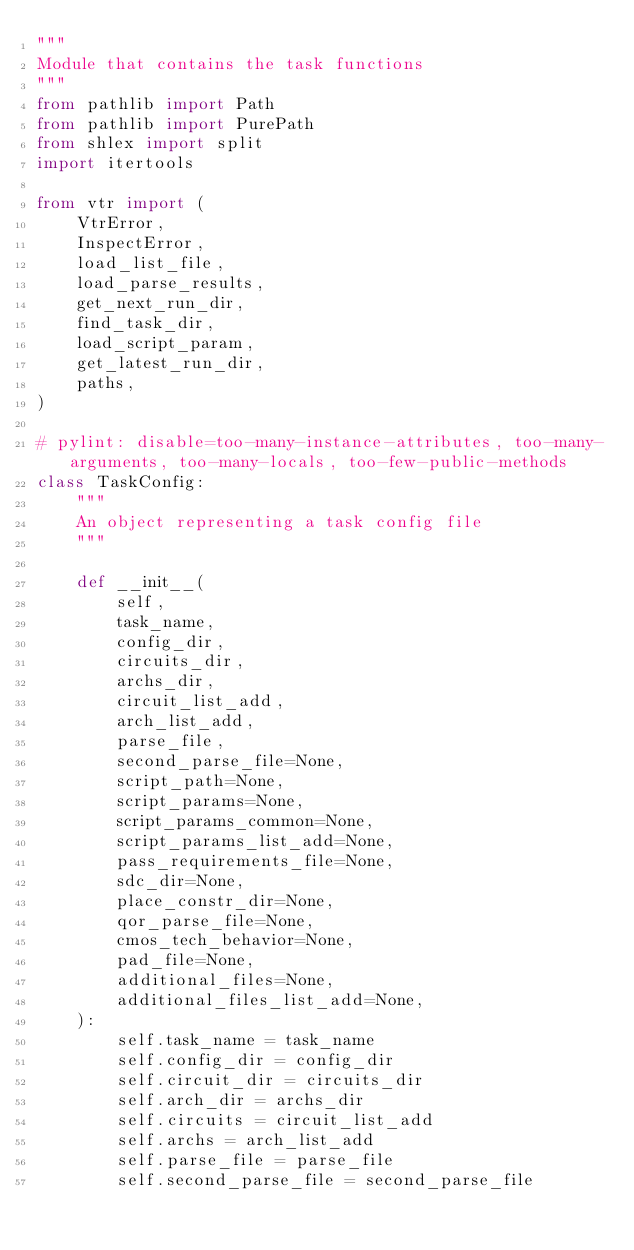<code> <loc_0><loc_0><loc_500><loc_500><_Python_>"""
Module that contains the task functions
"""
from pathlib import Path
from pathlib import PurePath
from shlex import split
import itertools

from vtr import (
    VtrError,
    InspectError,
    load_list_file,
    load_parse_results,
    get_next_run_dir,
    find_task_dir,
    load_script_param,
    get_latest_run_dir,
    paths,
)

# pylint: disable=too-many-instance-attributes, too-many-arguments, too-many-locals, too-few-public-methods
class TaskConfig:
    """
    An object representing a task config file
    """

    def __init__(
        self,
        task_name,
        config_dir,
        circuits_dir,
        archs_dir,
        circuit_list_add,
        arch_list_add,
        parse_file,
        second_parse_file=None,
        script_path=None,
        script_params=None,
        script_params_common=None,
        script_params_list_add=None,
        pass_requirements_file=None,
        sdc_dir=None,
        place_constr_dir=None,
        qor_parse_file=None,
        cmos_tech_behavior=None,
        pad_file=None,
        additional_files=None,
        additional_files_list_add=None,
    ):
        self.task_name = task_name
        self.config_dir = config_dir
        self.circuit_dir = circuits_dir
        self.arch_dir = archs_dir
        self.circuits = circuit_list_add
        self.archs = arch_list_add
        self.parse_file = parse_file
        self.second_parse_file = second_parse_file</code> 